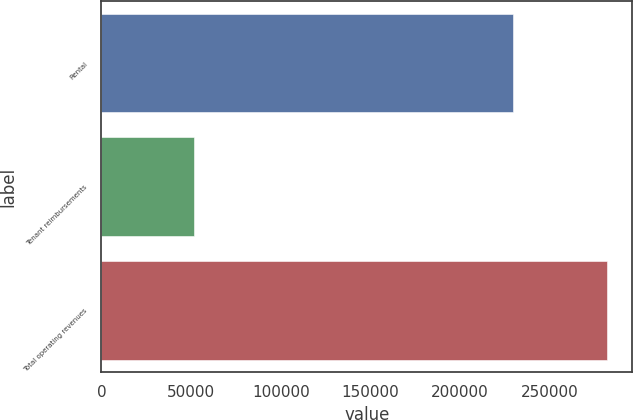<chart> <loc_0><loc_0><loc_500><loc_500><bar_chart><fcel>Rental<fcel>Tenant reimbursements<fcel>Total operating revenues<nl><fcel>229742<fcel>51796<fcel>281903<nl></chart> 